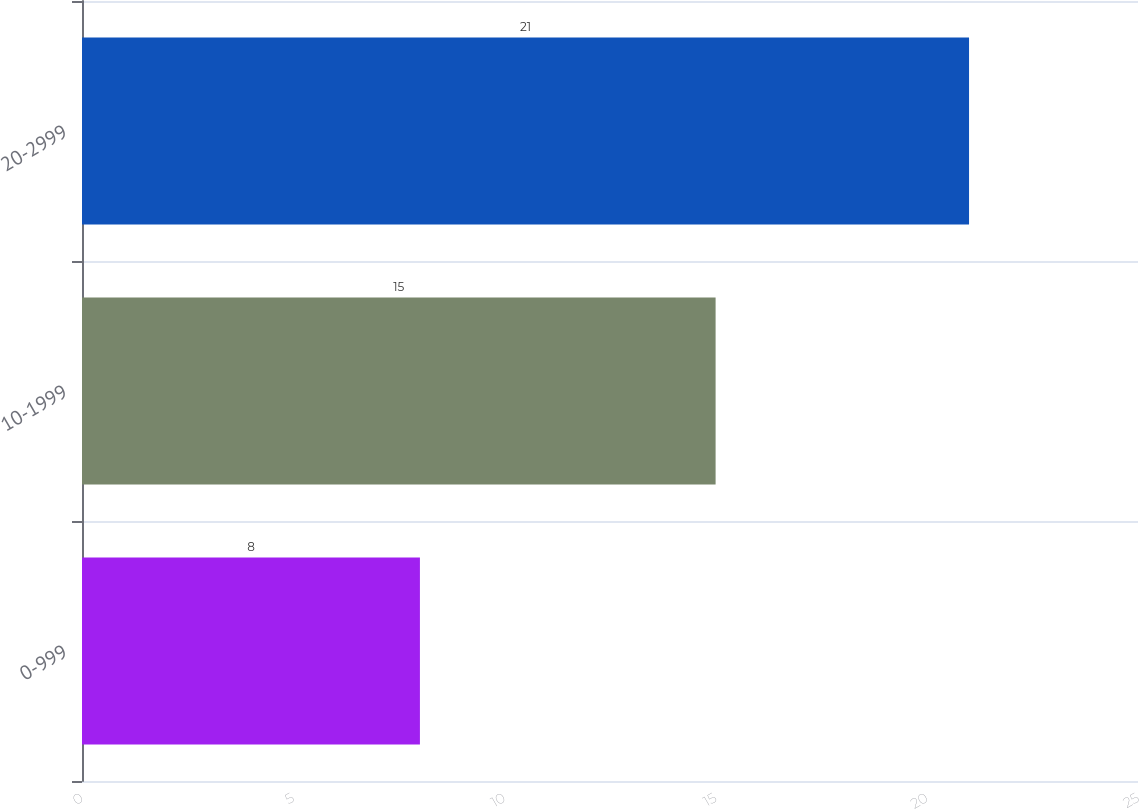<chart> <loc_0><loc_0><loc_500><loc_500><bar_chart><fcel>0-999<fcel>10-1999<fcel>20-2999<nl><fcel>8<fcel>15<fcel>21<nl></chart> 